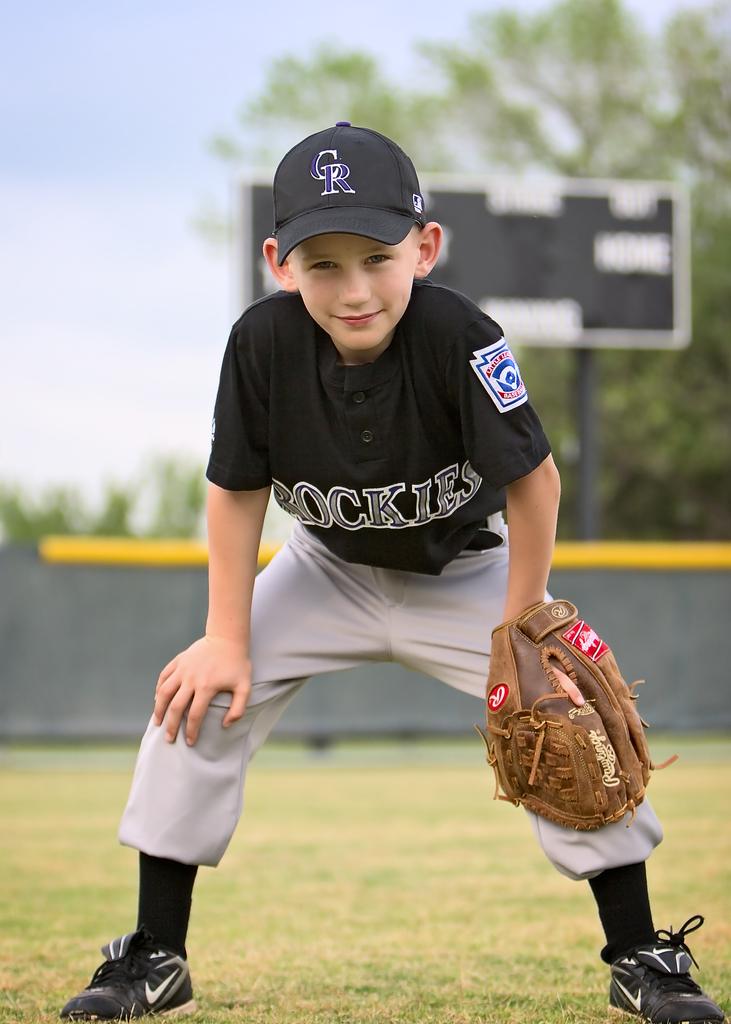What is the name of the team?
Ensure brevity in your answer.  Rockies. 